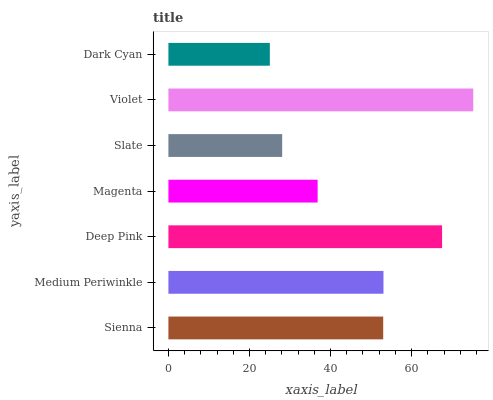Is Dark Cyan the minimum?
Answer yes or no. Yes. Is Violet the maximum?
Answer yes or no. Yes. Is Medium Periwinkle the minimum?
Answer yes or no. No. Is Medium Periwinkle the maximum?
Answer yes or no. No. Is Medium Periwinkle greater than Sienna?
Answer yes or no. Yes. Is Sienna less than Medium Periwinkle?
Answer yes or no. Yes. Is Sienna greater than Medium Periwinkle?
Answer yes or no. No. Is Medium Periwinkle less than Sienna?
Answer yes or no. No. Is Sienna the high median?
Answer yes or no. Yes. Is Sienna the low median?
Answer yes or no. Yes. Is Dark Cyan the high median?
Answer yes or no. No. Is Medium Periwinkle the low median?
Answer yes or no. No. 